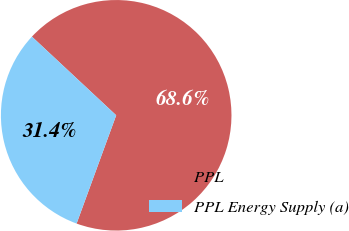Convert chart. <chart><loc_0><loc_0><loc_500><loc_500><pie_chart><fcel>PPL<fcel>PPL Energy Supply (a)<nl><fcel>68.63%<fcel>31.37%<nl></chart> 